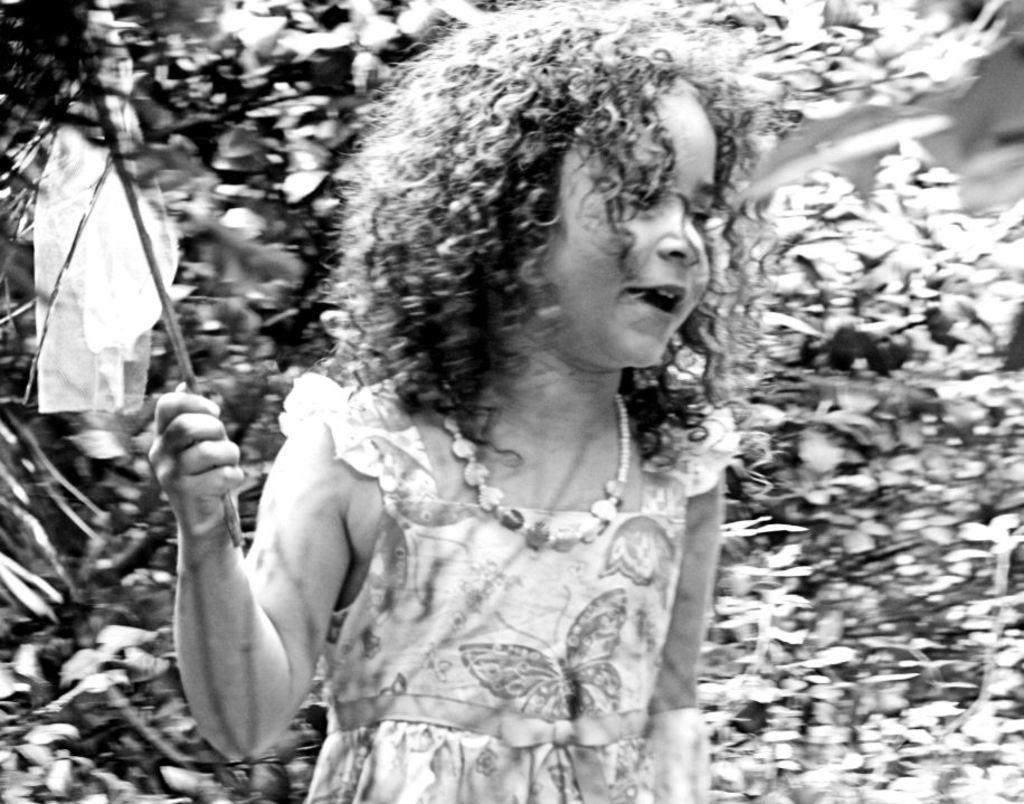What is the color scheme of the image? The image is black and white. Who is the main subject in the image? There is a girl in the image. What is the girl wearing? The girl is wearing a frock. What is the girl holding in her hand? The girl is holding a flag in her hand. Which direction is the girl facing? The girl is facing towards the right side. What can be seen in the background of the image? There are plants in the background of the image. What type of wave can be seen crashing on the shore in the image? There is no wave or shore present in the image; it features a girl holding a flag in a black and white setting with plants in the background. 